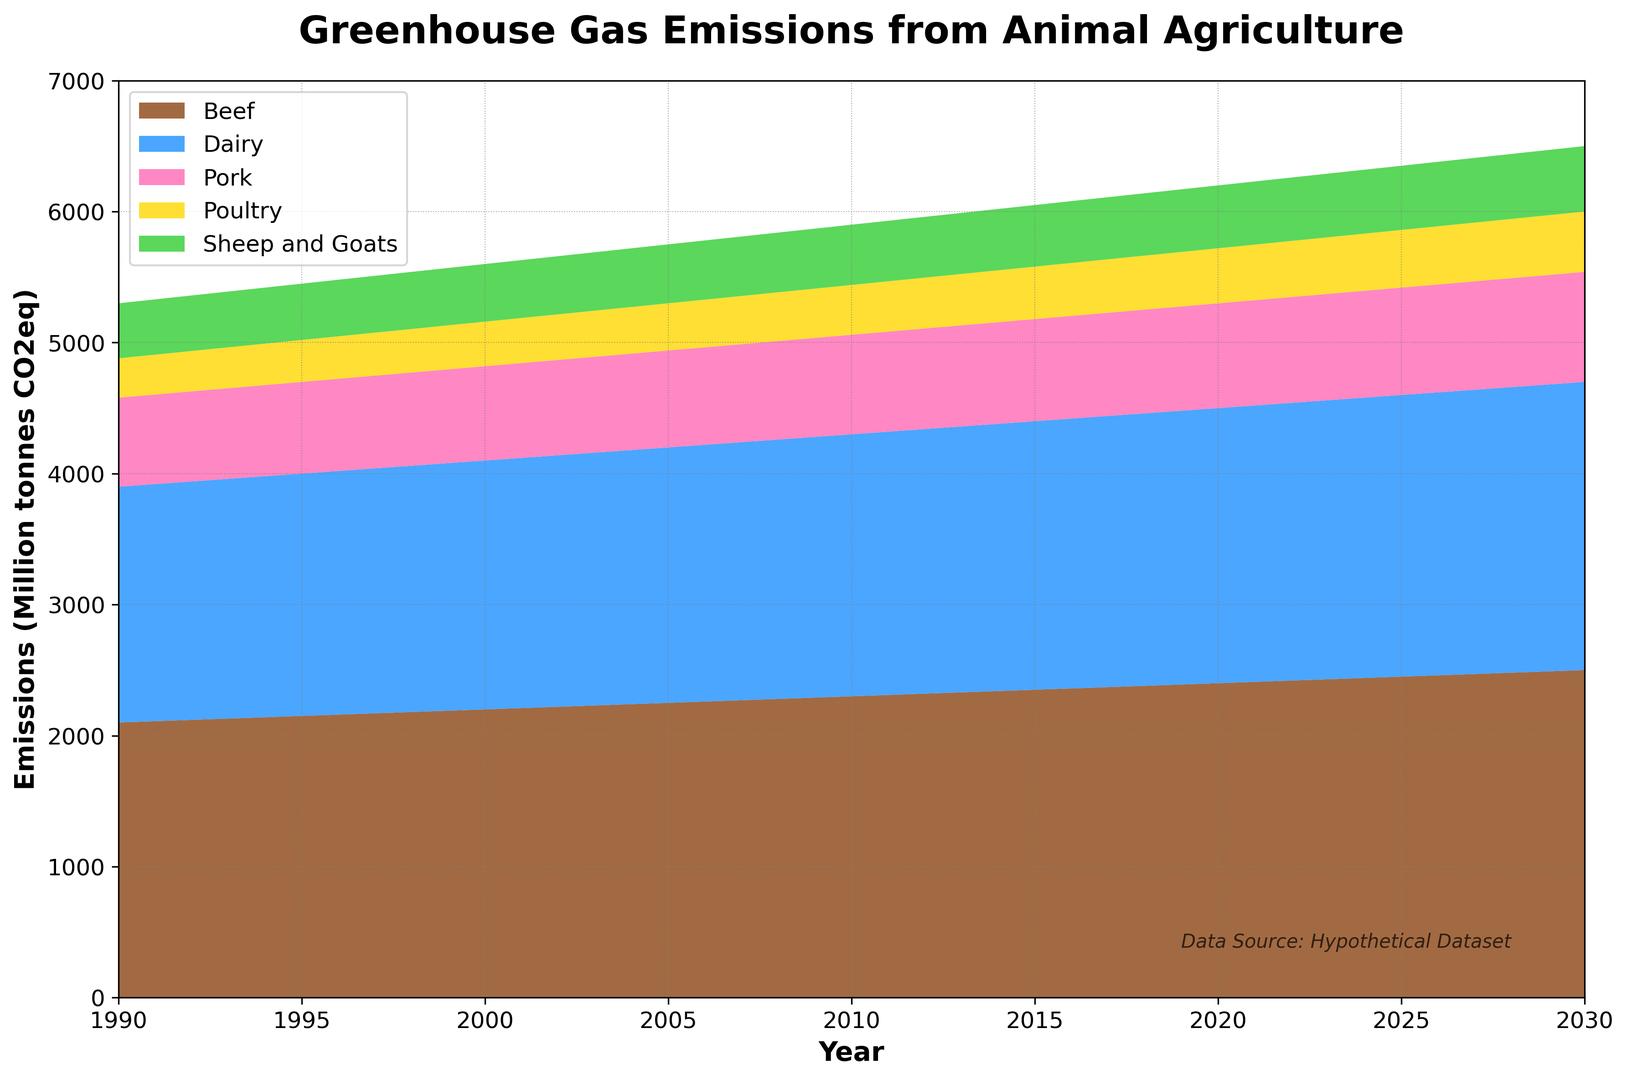How has the emission for Beef changed from 1990 to 2030? To determine the change in emissions for Beef from 1990 to 2030, we look at the starting value in 1990 and the final value in 2030. The emission starts at 2100 in 1990 and increases to 2500 in 2030. Thus, the change is 2500 - 2100.
Answer: 400 Between 1995 and 2010, which sector saw the highest percentage increase in emissions? To find the highest percentage increase, we first calculate the percentage increase for each sector: ((emission in 2010 - emission in 1995) / emission in 1995) * 100. For Beef: ((2300 - 2150) / 2150) * 100 = 6.98%, Dairy: ((2000 - 1850) / 1850) * 100 = 8.11%, Pork: ((760 - 700) / 700) * 100 = 8.57%, Poultry: ((380 - 320) / 320) * 100 = 18.75%, Sheep and Goats: ((460 - 430) / 430) * 100 = 6.98%. Poultry has the highest percentage increase.
Answer: Poultry In which year did Dairy emissions surpass 2000 million tonnes for the first time? From the chart, we observe the emission values for Dairy and see that the value surpasses 2000 million tonnes in 2020 where the emission is exactly 2000 in 2015 and 2100 in 2020.
Answer: 2020 What is the combined emission from Poultry and Pork in 2025? To find the combined emission, we sum the values for Poultry and Pork in 2025. Poultry has an emission of 440, and Pork has an emission of 820, giving us a total of 440 + 820.
Answer: 1260 Which sector has consistently shown the lowest greenhouse gas emissions across all years? We observe the emission values for each sector from 1990 to 2030. The sector with the lowest values throughout the period is Poultry.
Answer: Poultry How much did total greenhouse gas emissions from all sectors increase from 1990 to 2025? First, sum the emissions from all sectors for each year, then find the difference: (1990: 2100 + 1800 + 680 + 300 + 420 = 5300) and (2025: 2450 + 2150 + 820 + 440 + 490 = 6350). The increase is 6350 - 5300.
Answer: 1050 How do the emissions from Dairy in 2000 compare to that of Sheep and Goats in 2015? Compare the values for Dairy in 2000 and Sheep and Goats in 2015. Dairy in 2000 is 1900; Sheep and Goats in 2015 is 470. Dairy's emission is higher than Sheep and Goats' by 1900 - 470.
Answer: 1430 What's the trend in emissions for the sector with the green color in the figure? The green color represents Sheep and Goats. Observing the trend from 1990 to 2030, the emissions gradually increase since the emissions go from 420 in 1990 to 500 in 2030.
Answer: Increasing Which year shows the highest total emissions from all sectors combined? By calculating the total emissions for all sectors per year, we see the highest value visually from the stacked area chart in 2030.
Answer: 2030 What were the emissions levels for Beef and Dairy in 2010, and what is their difference? Check the emissions values for Beef and Dairy in 2010. Beef is at 2300, and Dairy is at 2000. The difference can be calculated as 2300 - 2000.
Answer: 300 